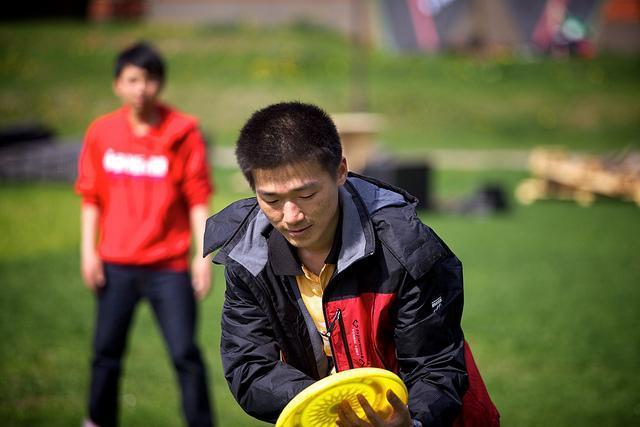How many people have black hair?
Give a very brief answer. 2. How many women?
Give a very brief answer. 0. How many people are there?
Give a very brief answer. 2. 